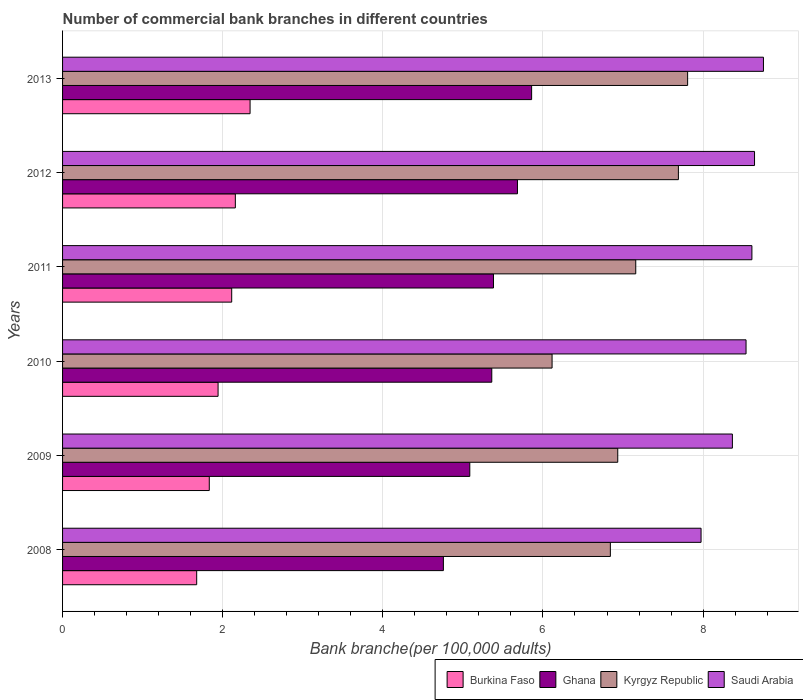How many different coloured bars are there?
Keep it short and to the point. 4. How many groups of bars are there?
Your response must be concise. 6. Are the number of bars per tick equal to the number of legend labels?
Keep it short and to the point. Yes. Are the number of bars on each tick of the Y-axis equal?
Keep it short and to the point. Yes. How many bars are there on the 1st tick from the top?
Keep it short and to the point. 4. What is the label of the 5th group of bars from the top?
Your response must be concise. 2009. In how many cases, is the number of bars for a given year not equal to the number of legend labels?
Ensure brevity in your answer.  0. What is the number of commercial bank branches in Saudi Arabia in 2013?
Give a very brief answer. 8.75. Across all years, what is the maximum number of commercial bank branches in Saudi Arabia?
Ensure brevity in your answer.  8.75. Across all years, what is the minimum number of commercial bank branches in Kyrgyz Republic?
Your response must be concise. 6.11. What is the total number of commercial bank branches in Ghana in the graph?
Make the answer very short. 32.13. What is the difference between the number of commercial bank branches in Kyrgyz Republic in 2010 and that in 2012?
Give a very brief answer. -1.58. What is the difference between the number of commercial bank branches in Saudi Arabia in 2010 and the number of commercial bank branches in Kyrgyz Republic in 2011?
Provide a short and direct response. 1.38. What is the average number of commercial bank branches in Ghana per year?
Your answer should be very brief. 5.35. In the year 2012, what is the difference between the number of commercial bank branches in Ghana and number of commercial bank branches in Kyrgyz Republic?
Offer a very short reply. -2.01. What is the ratio of the number of commercial bank branches in Ghana in 2012 to that in 2013?
Your answer should be very brief. 0.97. Is the number of commercial bank branches in Ghana in 2008 less than that in 2012?
Keep it short and to the point. Yes. What is the difference between the highest and the second highest number of commercial bank branches in Kyrgyz Republic?
Your answer should be compact. 0.12. What is the difference between the highest and the lowest number of commercial bank branches in Burkina Faso?
Provide a succinct answer. 0.67. Is the sum of the number of commercial bank branches in Ghana in 2008 and 2009 greater than the maximum number of commercial bank branches in Burkina Faso across all years?
Give a very brief answer. Yes. Is it the case that in every year, the sum of the number of commercial bank branches in Ghana and number of commercial bank branches in Burkina Faso is greater than the sum of number of commercial bank branches in Kyrgyz Republic and number of commercial bank branches in Saudi Arabia?
Your response must be concise. No. What does the 1st bar from the top in 2013 represents?
Offer a very short reply. Saudi Arabia. What does the 4th bar from the bottom in 2013 represents?
Provide a short and direct response. Saudi Arabia. Is it the case that in every year, the sum of the number of commercial bank branches in Burkina Faso and number of commercial bank branches in Kyrgyz Republic is greater than the number of commercial bank branches in Saudi Arabia?
Offer a very short reply. No. What is the difference between two consecutive major ticks on the X-axis?
Give a very brief answer. 2. Does the graph contain any zero values?
Make the answer very short. No. Does the graph contain grids?
Your response must be concise. Yes. Where does the legend appear in the graph?
Your answer should be very brief. Bottom right. What is the title of the graph?
Provide a short and direct response. Number of commercial bank branches in different countries. What is the label or title of the X-axis?
Provide a succinct answer. Bank branche(per 100,0 adults). What is the label or title of the Y-axis?
Offer a terse response. Years. What is the Bank branche(per 100,000 adults) of Burkina Faso in 2008?
Make the answer very short. 1.68. What is the Bank branche(per 100,000 adults) of Ghana in 2008?
Offer a very short reply. 4.76. What is the Bank branche(per 100,000 adults) of Kyrgyz Republic in 2008?
Ensure brevity in your answer.  6.84. What is the Bank branche(per 100,000 adults) of Saudi Arabia in 2008?
Your answer should be very brief. 7.97. What is the Bank branche(per 100,000 adults) of Burkina Faso in 2009?
Your answer should be very brief. 1.83. What is the Bank branche(per 100,000 adults) of Ghana in 2009?
Your answer should be very brief. 5.09. What is the Bank branche(per 100,000 adults) of Kyrgyz Republic in 2009?
Ensure brevity in your answer.  6.93. What is the Bank branche(per 100,000 adults) of Saudi Arabia in 2009?
Keep it short and to the point. 8.37. What is the Bank branche(per 100,000 adults) of Burkina Faso in 2010?
Your answer should be very brief. 1.94. What is the Bank branche(per 100,000 adults) in Ghana in 2010?
Keep it short and to the point. 5.36. What is the Bank branche(per 100,000 adults) in Kyrgyz Republic in 2010?
Provide a short and direct response. 6.11. What is the Bank branche(per 100,000 adults) in Saudi Arabia in 2010?
Your answer should be very brief. 8.54. What is the Bank branche(per 100,000 adults) of Burkina Faso in 2011?
Give a very brief answer. 2.11. What is the Bank branche(per 100,000 adults) of Ghana in 2011?
Your answer should be very brief. 5.38. What is the Bank branche(per 100,000 adults) in Kyrgyz Republic in 2011?
Provide a short and direct response. 7.16. What is the Bank branche(per 100,000 adults) of Saudi Arabia in 2011?
Ensure brevity in your answer.  8.61. What is the Bank branche(per 100,000 adults) of Burkina Faso in 2012?
Offer a terse response. 2.16. What is the Bank branche(per 100,000 adults) of Ghana in 2012?
Offer a very short reply. 5.68. What is the Bank branche(per 100,000 adults) in Kyrgyz Republic in 2012?
Ensure brevity in your answer.  7.69. What is the Bank branche(per 100,000 adults) of Saudi Arabia in 2012?
Ensure brevity in your answer.  8.64. What is the Bank branche(per 100,000 adults) in Burkina Faso in 2013?
Provide a short and direct response. 2.34. What is the Bank branche(per 100,000 adults) in Ghana in 2013?
Offer a terse response. 5.86. What is the Bank branche(per 100,000 adults) of Kyrgyz Republic in 2013?
Your response must be concise. 7.81. What is the Bank branche(per 100,000 adults) in Saudi Arabia in 2013?
Your answer should be very brief. 8.75. Across all years, what is the maximum Bank branche(per 100,000 adults) of Burkina Faso?
Offer a terse response. 2.34. Across all years, what is the maximum Bank branche(per 100,000 adults) of Ghana?
Offer a terse response. 5.86. Across all years, what is the maximum Bank branche(per 100,000 adults) of Kyrgyz Republic?
Your response must be concise. 7.81. Across all years, what is the maximum Bank branche(per 100,000 adults) of Saudi Arabia?
Your response must be concise. 8.75. Across all years, what is the minimum Bank branche(per 100,000 adults) in Burkina Faso?
Provide a succinct answer. 1.68. Across all years, what is the minimum Bank branche(per 100,000 adults) in Ghana?
Give a very brief answer. 4.76. Across all years, what is the minimum Bank branche(per 100,000 adults) in Kyrgyz Republic?
Offer a very short reply. 6.11. Across all years, what is the minimum Bank branche(per 100,000 adults) of Saudi Arabia?
Your response must be concise. 7.97. What is the total Bank branche(per 100,000 adults) in Burkina Faso in the graph?
Your answer should be very brief. 12.06. What is the total Bank branche(per 100,000 adults) in Ghana in the graph?
Provide a short and direct response. 32.13. What is the total Bank branche(per 100,000 adults) in Kyrgyz Republic in the graph?
Keep it short and to the point. 42.55. What is the total Bank branche(per 100,000 adults) of Saudi Arabia in the graph?
Your response must be concise. 50.88. What is the difference between the Bank branche(per 100,000 adults) of Burkina Faso in 2008 and that in 2009?
Provide a succinct answer. -0.16. What is the difference between the Bank branche(per 100,000 adults) in Ghana in 2008 and that in 2009?
Provide a short and direct response. -0.33. What is the difference between the Bank branche(per 100,000 adults) in Kyrgyz Republic in 2008 and that in 2009?
Your response must be concise. -0.09. What is the difference between the Bank branche(per 100,000 adults) in Saudi Arabia in 2008 and that in 2009?
Provide a succinct answer. -0.39. What is the difference between the Bank branche(per 100,000 adults) of Burkina Faso in 2008 and that in 2010?
Offer a terse response. -0.27. What is the difference between the Bank branche(per 100,000 adults) of Ghana in 2008 and that in 2010?
Provide a succinct answer. -0.6. What is the difference between the Bank branche(per 100,000 adults) of Kyrgyz Republic in 2008 and that in 2010?
Your answer should be compact. 0.73. What is the difference between the Bank branche(per 100,000 adults) of Saudi Arabia in 2008 and that in 2010?
Give a very brief answer. -0.56. What is the difference between the Bank branche(per 100,000 adults) of Burkina Faso in 2008 and that in 2011?
Ensure brevity in your answer.  -0.44. What is the difference between the Bank branche(per 100,000 adults) in Ghana in 2008 and that in 2011?
Offer a very short reply. -0.63. What is the difference between the Bank branche(per 100,000 adults) of Kyrgyz Republic in 2008 and that in 2011?
Offer a terse response. -0.32. What is the difference between the Bank branche(per 100,000 adults) of Saudi Arabia in 2008 and that in 2011?
Offer a very short reply. -0.63. What is the difference between the Bank branche(per 100,000 adults) of Burkina Faso in 2008 and that in 2012?
Give a very brief answer. -0.48. What is the difference between the Bank branche(per 100,000 adults) of Ghana in 2008 and that in 2012?
Provide a short and direct response. -0.93. What is the difference between the Bank branche(per 100,000 adults) in Kyrgyz Republic in 2008 and that in 2012?
Offer a terse response. -0.85. What is the difference between the Bank branche(per 100,000 adults) in Saudi Arabia in 2008 and that in 2012?
Keep it short and to the point. -0.67. What is the difference between the Bank branche(per 100,000 adults) of Burkina Faso in 2008 and that in 2013?
Your answer should be very brief. -0.67. What is the difference between the Bank branche(per 100,000 adults) of Ghana in 2008 and that in 2013?
Your response must be concise. -1.1. What is the difference between the Bank branche(per 100,000 adults) of Kyrgyz Republic in 2008 and that in 2013?
Provide a succinct answer. -0.96. What is the difference between the Bank branche(per 100,000 adults) in Saudi Arabia in 2008 and that in 2013?
Ensure brevity in your answer.  -0.78. What is the difference between the Bank branche(per 100,000 adults) of Burkina Faso in 2009 and that in 2010?
Make the answer very short. -0.11. What is the difference between the Bank branche(per 100,000 adults) in Ghana in 2009 and that in 2010?
Offer a terse response. -0.27. What is the difference between the Bank branche(per 100,000 adults) of Kyrgyz Republic in 2009 and that in 2010?
Ensure brevity in your answer.  0.82. What is the difference between the Bank branche(per 100,000 adults) of Saudi Arabia in 2009 and that in 2010?
Provide a succinct answer. -0.17. What is the difference between the Bank branche(per 100,000 adults) of Burkina Faso in 2009 and that in 2011?
Your response must be concise. -0.28. What is the difference between the Bank branche(per 100,000 adults) of Ghana in 2009 and that in 2011?
Your answer should be compact. -0.3. What is the difference between the Bank branche(per 100,000 adults) in Kyrgyz Republic in 2009 and that in 2011?
Give a very brief answer. -0.22. What is the difference between the Bank branche(per 100,000 adults) of Saudi Arabia in 2009 and that in 2011?
Offer a terse response. -0.24. What is the difference between the Bank branche(per 100,000 adults) of Burkina Faso in 2009 and that in 2012?
Ensure brevity in your answer.  -0.33. What is the difference between the Bank branche(per 100,000 adults) of Ghana in 2009 and that in 2012?
Keep it short and to the point. -0.6. What is the difference between the Bank branche(per 100,000 adults) in Kyrgyz Republic in 2009 and that in 2012?
Offer a terse response. -0.76. What is the difference between the Bank branche(per 100,000 adults) of Saudi Arabia in 2009 and that in 2012?
Give a very brief answer. -0.28. What is the difference between the Bank branche(per 100,000 adults) of Burkina Faso in 2009 and that in 2013?
Make the answer very short. -0.51. What is the difference between the Bank branche(per 100,000 adults) of Ghana in 2009 and that in 2013?
Keep it short and to the point. -0.77. What is the difference between the Bank branche(per 100,000 adults) in Kyrgyz Republic in 2009 and that in 2013?
Your answer should be very brief. -0.87. What is the difference between the Bank branche(per 100,000 adults) in Saudi Arabia in 2009 and that in 2013?
Ensure brevity in your answer.  -0.39. What is the difference between the Bank branche(per 100,000 adults) of Burkina Faso in 2010 and that in 2011?
Your answer should be compact. -0.17. What is the difference between the Bank branche(per 100,000 adults) in Ghana in 2010 and that in 2011?
Your response must be concise. -0.02. What is the difference between the Bank branche(per 100,000 adults) of Kyrgyz Republic in 2010 and that in 2011?
Your answer should be very brief. -1.05. What is the difference between the Bank branche(per 100,000 adults) in Saudi Arabia in 2010 and that in 2011?
Provide a short and direct response. -0.07. What is the difference between the Bank branche(per 100,000 adults) of Burkina Faso in 2010 and that in 2012?
Provide a short and direct response. -0.22. What is the difference between the Bank branche(per 100,000 adults) of Ghana in 2010 and that in 2012?
Offer a terse response. -0.32. What is the difference between the Bank branche(per 100,000 adults) in Kyrgyz Republic in 2010 and that in 2012?
Offer a very short reply. -1.58. What is the difference between the Bank branche(per 100,000 adults) in Saudi Arabia in 2010 and that in 2012?
Provide a succinct answer. -0.11. What is the difference between the Bank branche(per 100,000 adults) in Burkina Faso in 2010 and that in 2013?
Offer a terse response. -0.4. What is the difference between the Bank branche(per 100,000 adults) of Ghana in 2010 and that in 2013?
Offer a very short reply. -0.5. What is the difference between the Bank branche(per 100,000 adults) of Kyrgyz Republic in 2010 and that in 2013?
Give a very brief answer. -1.69. What is the difference between the Bank branche(per 100,000 adults) in Saudi Arabia in 2010 and that in 2013?
Offer a very short reply. -0.22. What is the difference between the Bank branche(per 100,000 adults) of Burkina Faso in 2011 and that in 2012?
Ensure brevity in your answer.  -0.05. What is the difference between the Bank branche(per 100,000 adults) of Ghana in 2011 and that in 2012?
Your response must be concise. -0.3. What is the difference between the Bank branche(per 100,000 adults) in Kyrgyz Republic in 2011 and that in 2012?
Your answer should be compact. -0.53. What is the difference between the Bank branche(per 100,000 adults) in Saudi Arabia in 2011 and that in 2012?
Give a very brief answer. -0.03. What is the difference between the Bank branche(per 100,000 adults) of Burkina Faso in 2011 and that in 2013?
Give a very brief answer. -0.23. What is the difference between the Bank branche(per 100,000 adults) in Ghana in 2011 and that in 2013?
Ensure brevity in your answer.  -0.48. What is the difference between the Bank branche(per 100,000 adults) in Kyrgyz Republic in 2011 and that in 2013?
Offer a very short reply. -0.65. What is the difference between the Bank branche(per 100,000 adults) in Saudi Arabia in 2011 and that in 2013?
Give a very brief answer. -0.14. What is the difference between the Bank branche(per 100,000 adults) of Burkina Faso in 2012 and that in 2013?
Provide a short and direct response. -0.18. What is the difference between the Bank branche(per 100,000 adults) of Ghana in 2012 and that in 2013?
Your answer should be compact. -0.18. What is the difference between the Bank branche(per 100,000 adults) in Kyrgyz Republic in 2012 and that in 2013?
Provide a succinct answer. -0.12. What is the difference between the Bank branche(per 100,000 adults) of Saudi Arabia in 2012 and that in 2013?
Your answer should be compact. -0.11. What is the difference between the Bank branche(per 100,000 adults) in Burkina Faso in 2008 and the Bank branche(per 100,000 adults) in Ghana in 2009?
Give a very brief answer. -3.41. What is the difference between the Bank branche(per 100,000 adults) of Burkina Faso in 2008 and the Bank branche(per 100,000 adults) of Kyrgyz Republic in 2009?
Provide a succinct answer. -5.26. What is the difference between the Bank branche(per 100,000 adults) of Burkina Faso in 2008 and the Bank branche(per 100,000 adults) of Saudi Arabia in 2009?
Your answer should be very brief. -6.69. What is the difference between the Bank branche(per 100,000 adults) of Ghana in 2008 and the Bank branche(per 100,000 adults) of Kyrgyz Republic in 2009?
Give a very brief answer. -2.18. What is the difference between the Bank branche(per 100,000 adults) of Ghana in 2008 and the Bank branche(per 100,000 adults) of Saudi Arabia in 2009?
Give a very brief answer. -3.61. What is the difference between the Bank branche(per 100,000 adults) of Kyrgyz Republic in 2008 and the Bank branche(per 100,000 adults) of Saudi Arabia in 2009?
Your response must be concise. -1.52. What is the difference between the Bank branche(per 100,000 adults) in Burkina Faso in 2008 and the Bank branche(per 100,000 adults) in Ghana in 2010?
Give a very brief answer. -3.69. What is the difference between the Bank branche(per 100,000 adults) in Burkina Faso in 2008 and the Bank branche(per 100,000 adults) in Kyrgyz Republic in 2010?
Provide a succinct answer. -4.44. What is the difference between the Bank branche(per 100,000 adults) in Burkina Faso in 2008 and the Bank branche(per 100,000 adults) in Saudi Arabia in 2010?
Keep it short and to the point. -6.86. What is the difference between the Bank branche(per 100,000 adults) in Ghana in 2008 and the Bank branche(per 100,000 adults) in Kyrgyz Republic in 2010?
Ensure brevity in your answer.  -1.36. What is the difference between the Bank branche(per 100,000 adults) in Ghana in 2008 and the Bank branche(per 100,000 adults) in Saudi Arabia in 2010?
Offer a very short reply. -3.78. What is the difference between the Bank branche(per 100,000 adults) of Kyrgyz Republic in 2008 and the Bank branche(per 100,000 adults) of Saudi Arabia in 2010?
Make the answer very short. -1.69. What is the difference between the Bank branche(per 100,000 adults) of Burkina Faso in 2008 and the Bank branche(per 100,000 adults) of Ghana in 2011?
Your answer should be compact. -3.71. What is the difference between the Bank branche(per 100,000 adults) of Burkina Faso in 2008 and the Bank branche(per 100,000 adults) of Kyrgyz Republic in 2011?
Keep it short and to the point. -5.48. What is the difference between the Bank branche(per 100,000 adults) in Burkina Faso in 2008 and the Bank branche(per 100,000 adults) in Saudi Arabia in 2011?
Make the answer very short. -6.93. What is the difference between the Bank branche(per 100,000 adults) of Ghana in 2008 and the Bank branche(per 100,000 adults) of Kyrgyz Republic in 2011?
Your answer should be very brief. -2.4. What is the difference between the Bank branche(per 100,000 adults) of Ghana in 2008 and the Bank branche(per 100,000 adults) of Saudi Arabia in 2011?
Make the answer very short. -3.85. What is the difference between the Bank branche(per 100,000 adults) of Kyrgyz Republic in 2008 and the Bank branche(per 100,000 adults) of Saudi Arabia in 2011?
Provide a succinct answer. -1.77. What is the difference between the Bank branche(per 100,000 adults) in Burkina Faso in 2008 and the Bank branche(per 100,000 adults) in Ghana in 2012?
Give a very brief answer. -4.01. What is the difference between the Bank branche(per 100,000 adults) of Burkina Faso in 2008 and the Bank branche(per 100,000 adults) of Kyrgyz Republic in 2012?
Provide a short and direct response. -6.02. What is the difference between the Bank branche(per 100,000 adults) of Burkina Faso in 2008 and the Bank branche(per 100,000 adults) of Saudi Arabia in 2012?
Your response must be concise. -6.97. What is the difference between the Bank branche(per 100,000 adults) in Ghana in 2008 and the Bank branche(per 100,000 adults) in Kyrgyz Republic in 2012?
Keep it short and to the point. -2.94. What is the difference between the Bank branche(per 100,000 adults) in Ghana in 2008 and the Bank branche(per 100,000 adults) in Saudi Arabia in 2012?
Offer a terse response. -3.89. What is the difference between the Bank branche(per 100,000 adults) in Kyrgyz Republic in 2008 and the Bank branche(per 100,000 adults) in Saudi Arabia in 2012?
Ensure brevity in your answer.  -1.8. What is the difference between the Bank branche(per 100,000 adults) in Burkina Faso in 2008 and the Bank branche(per 100,000 adults) in Ghana in 2013?
Provide a short and direct response. -4.18. What is the difference between the Bank branche(per 100,000 adults) in Burkina Faso in 2008 and the Bank branche(per 100,000 adults) in Kyrgyz Republic in 2013?
Provide a short and direct response. -6.13. What is the difference between the Bank branche(per 100,000 adults) of Burkina Faso in 2008 and the Bank branche(per 100,000 adults) of Saudi Arabia in 2013?
Give a very brief answer. -7.08. What is the difference between the Bank branche(per 100,000 adults) in Ghana in 2008 and the Bank branche(per 100,000 adults) in Kyrgyz Republic in 2013?
Your response must be concise. -3.05. What is the difference between the Bank branche(per 100,000 adults) of Ghana in 2008 and the Bank branche(per 100,000 adults) of Saudi Arabia in 2013?
Keep it short and to the point. -4. What is the difference between the Bank branche(per 100,000 adults) of Kyrgyz Republic in 2008 and the Bank branche(per 100,000 adults) of Saudi Arabia in 2013?
Give a very brief answer. -1.91. What is the difference between the Bank branche(per 100,000 adults) of Burkina Faso in 2009 and the Bank branche(per 100,000 adults) of Ghana in 2010?
Make the answer very short. -3.53. What is the difference between the Bank branche(per 100,000 adults) of Burkina Faso in 2009 and the Bank branche(per 100,000 adults) of Kyrgyz Republic in 2010?
Offer a very short reply. -4.28. What is the difference between the Bank branche(per 100,000 adults) in Burkina Faso in 2009 and the Bank branche(per 100,000 adults) in Saudi Arabia in 2010?
Give a very brief answer. -6.7. What is the difference between the Bank branche(per 100,000 adults) in Ghana in 2009 and the Bank branche(per 100,000 adults) in Kyrgyz Republic in 2010?
Give a very brief answer. -1.03. What is the difference between the Bank branche(per 100,000 adults) of Ghana in 2009 and the Bank branche(per 100,000 adults) of Saudi Arabia in 2010?
Give a very brief answer. -3.45. What is the difference between the Bank branche(per 100,000 adults) of Kyrgyz Republic in 2009 and the Bank branche(per 100,000 adults) of Saudi Arabia in 2010?
Ensure brevity in your answer.  -1.6. What is the difference between the Bank branche(per 100,000 adults) of Burkina Faso in 2009 and the Bank branche(per 100,000 adults) of Ghana in 2011?
Provide a succinct answer. -3.55. What is the difference between the Bank branche(per 100,000 adults) in Burkina Faso in 2009 and the Bank branche(per 100,000 adults) in Kyrgyz Republic in 2011?
Offer a very short reply. -5.33. What is the difference between the Bank branche(per 100,000 adults) of Burkina Faso in 2009 and the Bank branche(per 100,000 adults) of Saudi Arabia in 2011?
Keep it short and to the point. -6.78. What is the difference between the Bank branche(per 100,000 adults) in Ghana in 2009 and the Bank branche(per 100,000 adults) in Kyrgyz Republic in 2011?
Make the answer very short. -2.07. What is the difference between the Bank branche(per 100,000 adults) in Ghana in 2009 and the Bank branche(per 100,000 adults) in Saudi Arabia in 2011?
Your answer should be compact. -3.52. What is the difference between the Bank branche(per 100,000 adults) of Kyrgyz Republic in 2009 and the Bank branche(per 100,000 adults) of Saudi Arabia in 2011?
Your answer should be very brief. -1.68. What is the difference between the Bank branche(per 100,000 adults) of Burkina Faso in 2009 and the Bank branche(per 100,000 adults) of Ghana in 2012?
Provide a succinct answer. -3.85. What is the difference between the Bank branche(per 100,000 adults) in Burkina Faso in 2009 and the Bank branche(per 100,000 adults) in Kyrgyz Republic in 2012?
Provide a short and direct response. -5.86. What is the difference between the Bank branche(per 100,000 adults) in Burkina Faso in 2009 and the Bank branche(per 100,000 adults) in Saudi Arabia in 2012?
Ensure brevity in your answer.  -6.81. What is the difference between the Bank branche(per 100,000 adults) in Ghana in 2009 and the Bank branche(per 100,000 adults) in Kyrgyz Republic in 2012?
Offer a very short reply. -2.61. What is the difference between the Bank branche(per 100,000 adults) of Ghana in 2009 and the Bank branche(per 100,000 adults) of Saudi Arabia in 2012?
Make the answer very short. -3.56. What is the difference between the Bank branche(per 100,000 adults) of Kyrgyz Republic in 2009 and the Bank branche(per 100,000 adults) of Saudi Arabia in 2012?
Provide a succinct answer. -1.71. What is the difference between the Bank branche(per 100,000 adults) in Burkina Faso in 2009 and the Bank branche(per 100,000 adults) in Ghana in 2013?
Offer a very short reply. -4.03. What is the difference between the Bank branche(per 100,000 adults) in Burkina Faso in 2009 and the Bank branche(per 100,000 adults) in Kyrgyz Republic in 2013?
Give a very brief answer. -5.97. What is the difference between the Bank branche(per 100,000 adults) in Burkina Faso in 2009 and the Bank branche(per 100,000 adults) in Saudi Arabia in 2013?
Make the answer very short. -6.92. What is the difference between the Bank branche(per 100,000 adults) in Ghana in 2009 and the Bank branche(per 100,000 adults) in Kyrgyz Republic in 2013?
Provide a succinct answer. -2.72. What is the difference between the Bank branche(per 100,000 adults) in Ghana in 2009 and the Bank branche(per 100,000 adults) in Saudi Arabia in 2013?
Your response must be concise. -3.67. What is the difference between the Bank branche(per 100,000 adults) in Kyrgyz Republic in 2009 and the Bank branche(per 100,000 adults) in Saudi Arabia in 2013?
Make the answer very short. -1.82. What is the difference between the Bank branche(per 100,000 adults) of Burkina Faso in 2010 and the Bank branche(per 100,000 adults) of Ghana in 2011?
Keep it short and to the point. -3.44. What is the difference between the Bank branche(per 100,000 adults) of Burkina Faso in 2010 and the Bank branche(per 100,000 adults) of Kyrgyz Republic in 2011?
Your answer should be compact. -5.22. What is the difference between the Bank branche(per 100,000 adults) in Burkina Faso in 2010 and the Bank branche(per 100,000 adults) in Saudi Arabia in 2011?
Your answer should be compact. -6.67. What is the difference between the Bank branche(per 100,000 adults) in Ghana in 2010 and the Bank branche(per 100,000 adults) in Kyrgyz Republic in 2011?
Offer a terse response. -1.8. What is the difference between the Bank branche(per 100,000 adults) in Ghana in 2010 and the Bank branche(per 100,000 adults) in Saudi Arabia in 2011?
Your response must be concise. -3.25. What is the difference between the Bank branche(per 100,000 adults) of Kyrgyz Republic in 2010 and the Bank branche(per 100,000 adults) of Saudi Arabia in 2011?
Provide a short and direct response. -2.5. What is the difference between the Bank branche(per 100,000 adults) in Burkina Faso in 2010 and the Bank branche(per 100,000 adults) in Ghana in 2012?
Keep it short and to the point. -3.74. What is the difference between the Bank branche(per 100,000 adults) in Burkina Faso in 2010 and the Bank branche(per 100,000 adults) in Kyrgyz Republic in 2012?
Offer a terse response. -5.75. What is the difference between the Bank branche(per 100,000 adults) in Burkina Faso in 2010 and the Bank branche(per 100,000 adults) in Saudi Arabia in 2012?
Offer a terse response. -6.7. What is the difference between the Bank branche(per 100,000 adults) of Ghana in 2010 and the Bank branche(per 100,000 adults) of Kyrgyz Republic in 2012?
Provide a succinct answer. -2.33. What is the difference between the Bank branche(per 100,000 adults) in Ghana in 2010 and the Bank branche(per 100,000 adults) in Saudi Arabia in 2012?
Your answer should be very brief. -3.28. What is the difference between the Bank branche(per 100,000 adults) of Kyrgyz Republic in 2010 and the Bank branche(per 100,000 adults) of Saudi Arabia in 2012?
Offer a terse response. -2.53. What is the difference between the Bank branche(per 100,000 adults) of Burkina Faso in 2010 and the Bank branche(per 100,000 adults) of Ghana in 2013?
Give a very brief answer. -3.92. What is the difference between the Bank branche(per 100,000 adults) in Burkina Faso in 2010 and the Bank branche(per 100,000 adults) in Kyrgyz Republic in 2013?
Your response must be concise. -5.86. What is the difference between the Bank branche(per 100,000 adults) in Burkina Faso in 2010 and the Bank branche(per 100,000 adults) in Saudi Arabia in 2013?
Offer a terse response. -6.81. What is the difference between the Bank branche(per 100,000 adults) of Ghana in 2010 and the Bank branche(per 100,000 adults) of Kyrgyz Republic in 2013?
Provide a short and direct response. -2.45. What is the difference between the Bank branche(per 100,000 adults) in Ghana in 2010 and the Bank branche(per 100,000 adults) in Saudi Arabia in 2013?
Your response must be concise. -3.39. What is the difference between the Bank branche(per 100,000 adults) of Kyrgyz Republic in 2010 and the Bank branche(per 100,000 adults) of Saudi Arabia in 2013?
Provide a short and direct response. -2.64. What is the difference between the Bank branche(per 100,000 adults) of Burkina Faso in 2011 and the Bank branche(per 100,000 adults) of Ghana in 2012?
Offer a very short reply. -3.57. What is the difference between the Bank branche(per 100,000 adults) in Burkina Faso in 2011 and the Bank branche(per 100,000 adults) in Kyrgyz Republic in 2012?
Give a very brief answer. -5.58. What is the difference between the Bank branche(per 100,000 adults) of Burkina Faso in 2011 and the Bank branche(per 100,000 adults) of Saudi Arabia in 2012?
Ensure brevity in your answer.  -6.53. What is the difference between the Bank branche(per 100,000 adults) in Ghana in 2011 and the Bank branche(per 100,000 adults) in Kyrgyz Republic in 2012?
Your answer should be compact. -2.31. What is the difference between the Bank branche(per 100,000 adults) in Ghana in 2011 and the Bank branche(per 100,000 adults) in Saudi Arabia in 2012?
Offer a terse response. -3.26. What is the difference between the Bank branche(per 100,000 adults) of Kyrgyz Republic in 2011 and the Bank branche(per 100,000 adults) of Saudi Arabia in 2012?
Make the answer very short. -1.48. What is the difference between the Bank branche(per 100,000 adults) of Burkina Faso in 2011 and the Bank branche(per 100,000 adults) of Ghana in 2013?
Your response must be concise. -3.75. What is the difference between the Bank branche(per 100,000 adults) in Burkina Faso in 2011 and the Bank branche(per 100,000 adults) in Kyrgyz Republic in 2013?
Give a very brief answer. -5.69. What is the difference between the Bank branche(per 100,000 adults) of Burkina Faso in 2011 and the Bank branche(per 100,000 adults) of Saudi Arabia in 2013?
Your response must be concise. -6.64. What is the difference between the Bank branche(per 100,000 adults) in Ghana in 2011 and the Bank branche(per 100,000 adults) in Kyrgyz Republic in 2013?
Keep it short and to the point. -2.42. What is the difference between the Bank branche(per 100,000 adults) in Ghana in 2011 and the Bank branche(per 100,000 adults) in Saudi Arabia in 2013?
Make the answer very short. -3.37. What is the difference between the Bank branche(per 100,000 adults) of Kyrgyz Republic in 2011 and the Bank branche(per 100,000 adults) of Saudi Arabia in 2013?
Your answer should be very brief. -1.59. What is the difference between the Bank branche(per 100,000 adults) in Burkina Faso in 2012 and the Bank branche(per 100,000 adults) in Ghana in 2013?
Your answer should be very brief. -3.7. What is the difference between the Bank branche(per 100,000 adults) of Burkina Faso in 2012 and the Bank branche(per 100,000 adults) of Kyrgyz Republic in 2013?
Provide a short and direct response. -5.65. What is the difference between the Bank branche(per 100,000 adults) of Burkina Faso in 2012 and the Bank branche(per 100,000 adults) of Saudi Arabia in 2013?
Make the answer very short. -6.6. What is the difference between the Bank branche(per 100,000 adults) of Ghana in 2012 and the Bank branche(per 100,000 adults) of Kyrgyz Republic in 2013?
Your response must be concise. -2.13. What is the difference between the Bank branche(per 100,000 adults) of Ghana in 2012 and the Bank branche(per 100,000 adults) of Saudi Arabia in 2013?
Offer a terse response. -3.07. What is the difference between the Bank branche(per 100,000 adults) in Kyrgyz Republic in 2012 and the Bank branche(per 100,000 adults) in Saudi Arabia in 2013?
Ensure brevity in your answer.  -1.06. What is the average Bank branche(per 100,000 adults) of Burkina Faso per year?
Ensure brevity in your answer.  2.01. What is the average Bank branche(per 100,000 adults) in Ghana per year?
Provide a short and direct response. 5.35. What is the average Bank branche(per 100,000 adults) of Kyrgyz Republic per year?
Your response must be concise. 7.09. What is the average Bank branche(per 100,000 adults) of Saudi Arabia per year?
Offer a very short reply. 8.48. In the year 2008, what is the difference between the Bank branche(per 100,000 adults) in Burkina Faso and Bank branche(per 100,000 adults) in Ghana?
Offer a very short reply. -3.08. In the year 2008, what is the difference between the Bank branche(per 100,000 adults) in Burkina Faso and Bank branche(per 100,000 adults) in Kyrgyz Republic?
Provide a short and direct response. -5.17. In the year 2008, what is the difference between the Bank branche(per 100,000 adults) in Burkina Faso and Bank branche(per 100,000 adults) in Saudi Arabia?
Keep it short and to the point. -6.3. In the year 2008, what is the difference between the Bank branche(per 100,000 adults) in Ghana and Bank branche(per 100,000 adults) in Kyrgyz Republic?
Make the answer very short. -2.09. In the year 2008, what is the difference between the Bank branche(per 100,000 adults) in Ghana and Bank branche(per 100,000 adults) in Saudi Arabia?
Offer a very short reply. -3.22. In the year 2008, what is the difference between the Bank branche(per 100,000 adults) in Kyrgyz Republic and Bank branche(per 100,000 adults) in Saudi Arabia?
Your answer should be very brief. -1.13. In the year 2009, what is the difference between the Bank branche(per 100,000 adults) in Burkina Faso and Bank branche(per 100,000 adults) in Ghana?
Provide a succinct answer. -3.25. In the year 2009, what is the difference between the Bank branche(per 100,000 adults) in Burkina Faso and Bank branche(per 100,000 adults) in Kyrgyz Republic?
Provide a short and direct response. -5.1. In the year 2009, what is the difference between the Bank branche(per 100,000 adults) of Burkina Faso and Bank branche(per 100,000 adults) of Saudi Arabia?
Offer a terse response. -6.53. In the year 2009, what is the difference between the Bank branche(per 100,000 adults) in Ghana and Bank branche(per 100,000 adults) in Kyrgyz Republic?
Ensure brevity in your answer.  -1.85. In the year 2009, what is the difference between the Bank branche(per 100,000 adults) in Ghana and Bank branche(per 100,000 adults) in Saudi Arabia?
Ensure brevity in your answer.  -3.28. In the year 2009, what is the difference between the Bank branche(per 100,000 adults) in Kyrgyz Republic and Bank branche(per 100,000 adults) in Saudi Arabia?
Your response must be concise. -1.43. In the year 2010, what is the difference between the Bank branche(per 100,000 adults) of Burkina Faso and Bank branche(per 100,000 adults) of Ghana?
Keep it short and to the point. -3.42. In the year 2010, what is the difference between the Bank branche(per 100,000 adults) in Burkina Faso and Bank branche(per 100,000 adults) in Kyrgyz Republic?
Ensure brevity in your answer.  -4.17. In the year 2010, what is the difference between the Bank branche(per 100,000 adults) in Burkina Faso and Bank branche(per 100,000 adults) in Saudi Arabia?
Offer a terse response. -6.59. In the year 2010, what is the difference between the Bank branche(per 100,000 adults) of Ghana and Bank branche(per 100,000 adults) of Kyrgyz Republic?
Offer a terse response. -0.75. In the year 2010, what is the difference between the Bank branche(per 100,000 adults) of Ghana and Bank branche(per 100,000 adults) of Saudi Arabia?
Your response must be concise. -3.18. In the year 2010, what is the difference between the Bank branche(per 100,000 adults) of Kyrgyz Republic and Bank branche(per 100,000 adults) of Saudi Arabia?
Ensure brevity in your answer.  -2.42. In the year 2011, what is the difference between the Bank branche(per 100,000 adults) of Burkina Faso and Bank branche(per 100,000 adults) of Ghana?
Provide a short and direct response. -3.27. In the year 2011, what is the difference between the Bank branche(per 100,000 adults) of Burkina Faso and Bank branche(per 100,000 adults) of Kyrgyz Republic?
Keep it short and to the point. -5.05. In the year 2011, what is the difference between the Bank branche(per 100,000 adults) of Burkina Faso and Bank branche(per 100,000 adults) of Saudi Arabia?
Keep it short and to the point. -6.5. In the year 2011, what is the difference between the Bank branche(per 100,000 adults) of Ghana and Bank branche(per 100,000 adults) of Kyrgyz Republic?
Provide a short and direct response. -1.78. In the year 2011, what is the difference between the Bank branche(per 100,000 adults) of Ghana and Bank branche(per 100,000 adults) of Saudi Arabia?
Ensure brevity in your answer.  -3.23. In the year 2011, what is the difference between the Bank branche(per 100,000 adults) of Kyrgyz Republic and Bank branche(per 100,000 adults) of Saudi Arabia?
Your response must be concise. -1.45. In the year 2012, what is the difference between the Bank branche(per 100,000 adults) of Burkina Faso and Bank branche(per 100,000 adults) of Ghana?
Offer a very short reply. -3.52. In the year 2012, what is the difference between the Bank branche(per 100,000 adults) of Burkina Faso and Bank branche(per 100,000 adults) of Kyrgyz Republic?
Provide a short and direct response. -5.53. In the year 2012, what is the difference between the Bank branche(per 100,000 adults) in Burkina Faso and Bank branche(per 100,000 adults) in Saudi Arabia?
Your answer should be compact. -6.48. In the year 2012, what is the difference between the Bank branche(per 100,000 adults) in Ghana and Bank branche(per 100,000 adults) in Kyrgyz Republic?
Provide a short and direct response. -2.01. In the year 2012, what is the difference between the Bank branche(per 100,000 adults) in Ghana and Bank branche(per 100,000 adults) in Saudi Arabia?
Provide a succinct answer. -2.96. In the year 2012, what is the difference between the Bank branche(per 100,000 adults) of Kyrgyz Republic and Bank branche(per 100,000 adults) of Saudi Arabia?
Ensure brevity in your answer.  -0.95. In the year 2013, what is the difference between the Bank branche(per 100,000 adults) of Burkina Faso and Bank branche(per 100,000 adults) of Ghana?
Offer a terse response. -3.52. In the year 2013, what is the difference between the Bank branche(per 100,000 adults) of Burkina Faso and Bank branche(per 100,000 adults) of Kyrgyz Republic?
Keep it short and to the point. -5.46. In the year 2013, what is the difference between the Bank branche(per 100,000 adults) of Burkina Faso and Bank branche(per 100,000 adults) of Saudi Arabia?
Offer a terse response. -6.41. In the year 2013, what is the difference between the Bank branche(per 100,000 adults) in Ghana and Bank branche(per 100,000 adults) in Kyrgyz Republic?
Your answer should be very brief. -1.95. In the year 2013, what is the difference between the Bank branche(per 100,000 adults) in Ghana and Bank branche(per 100,000 adults) in Saudi Arabia?
Provide a succinct answer. -2.9. In the year 2013, what is the difference between the Bank branche(per 100,000 adults) in Kyrgyz Republic and Bank branche(per 100,000 adults) in Saudi Arabia?
Your answer should be very brief. -0.95. What is the ratio of the Bank branche(per 100,000 adults) of Burkina Faso in 2008 to that in 2009?
Provide a short and direct response. 0.91. What is the ratio of the Bank branche(per 100,000 adults) of Ghana in 2008 to that in 2009?
Keep it short and to the point. 0.94. What is the ratio of the Bank branche(per 100,000 adults) of Kyrgyz Republic in 2008 to that in 2009?
Provide a short and direct response. 0.99. What is the ratio of the Bank branche(per 100,000 adults) of Saudi Arabia in 2008 to that in 2009?
Your answer should be compact. 0.95. What is the ratio of the Bank branche(per 100,000 adults) of Burkina Faso in 2008 to that in 2010?
Give a very brief answer. 0.86. What is the ratio of the Bank branche(per 100,000 adults) of Ghana in 2008 to that in 2010?
Give a very brief answer. 0.89. What is the ratio of the Bank branche(per 100,000 adults) of Kyrgyz Republic in 2008 to that in 2010?
Your answer should be very brief. 1.12. What is the ratio of the Bank branche(per 100,000 adults) in Saudi Arabia in 2008 to that in 2010?
Give a very brief answer. 0.93. What is the ratio of the Bank branche(per 100,000 adults) of Burkina Faso in 2008 to that in 2011?
Keep it short and to the point. 0.79. What is the ratio of the Bank branche(per 100,000 adults) of Ghana in 2008 to that in 2011?
Your answer should be compact. 0.88. What is the ratio of the Bank branche(per 100,000 adults) of Kyrgyz Republic in 2008 to that in 2011?
Give a very brief answer. 0.96. What is the ratio of the Bank branche(per 100,000 adults) in Saudi Arabia in 2008 to that in 2011?
Make the answer very short. 0.93. What is the ratio of the Bank branche(per 100,000 adults) of Burkina Faso in 2008 to that in 2012?
Your answer should be very brief. 0.78. What is the ratio of the Bank branche(per 100,000 adults) in Ghana in 2008 to that in 2012?
Your response must be concise. 0.84. What is the ratio of the Bank branche(per 100,000 adults) of Kyrgyz Republic in 2008 to that in 2012?
Provide a succinct answer. 0.89. What is the ratio of the Bank branche(per 100,000 adults) in Saudi Arabia in 2008 to that in 2012?
Offer a terse response. 0.92. What is the ratio of the Bank branche(per 100,000 adults) in Burkina Faso in 2008 to that in 2013?
Give a very brief answer. 0.72. What is the ratio of the Bank branche(per 100,000 adults) in Ghana in 2008 to that in 2013?
Your answer should be compact. 0.81. What is the ratio of the Bank branche(per 100,000 adults) in Kyrgyz Republic in 2008 to that in 2013?
Your answer should be very brief. 0.88. What is the ratio of the Bank branche(per 100,000 adults) of Saudi Arabia in 2008 to that in 2013?
Keep it short and to the point. 0.91. What is the ratio of the Bank branche(per 100,000 adults) of Burkina Faso in 2009 to that in 2010?
Give a very brief answer. 0.94. What is the ratio of the Bank branche(per 100,000 adults) of Ghana in 2009 to that in 2010?
Keep it short and to the point. 0.95. What is the ratio of the Bank branche(per 100,000 adults) in Kyrgyz Republic in 2009 to that in 2010?
Offer a terse response. 1.13. What is the ratio of the Bank branche(per 100,000 adults) of Burkina Faso in 2009 to that in 2011?
Ensure brevity in your answer.  0.87. What is the ratio of the Bank branche(per 100,000 adults) of Ghana in 2009 to that in 2011?
Make the answer very short. 0.94. What is the ratio of the Bank branche(per 100,000 adults) of Kyrgyz Republic in 2009 to that in 2011?
Offer a very short reply. 0.97. What is the ratio of the Bank branche(per 100,000 adults) of Saudi Arabia in 2009 to that in 2011?
Your answer should be compact. 0.97. What is the ratio of the Bank branche(per 100,000 adults) in Burkina Faso in 2009 to that in 2012?
Provide a short and direct response. 0.85. What is the ratio of the Bank branche(per 100,000 adults) in Ghana in 2009 to that in 2012?
Offer a very short reply. 0.9. What is the ratio of the Bank branche(per 100,000 adults) of Kyrgyz Republic in 2009 to that in 2012?
Offer a terse response. 0.9. What is the ratio of the Bank branche(per 100,000 adults) in Burkina Faso in 2009 to that in 2013?
Offer a very short reply. 0.78. What is the ratio of the Bank branche(per 100,000 adults) in Ghana in 2009 to that in 2013?
Give a very brief answer. 0.87. What is the ratio of the Bank branche(per 100,000 adults) in Kyrgyz Republic in 2009 to that in 2013?
Your response must be concise. 0.89. What is the ratio of the Bank branche(per 100,000 adults) of Saudi Arabia in 2009 to that in 2013?
Offer a terse response. 0.96. What is the ratio of the Bank branche(per 100,000 adults) in Burkina Faso in 2010 to that in 2011?
Provide a succinct answer. 0.92. What is the ratio of the Bank branche(per 100,000 adults) of Kyrgyz Republic in 2010 to that in 2011?
Your answer should be very brief. 0.85. What is the ratio of the Bank branche(per 100,000 adults) of Saudi Arabia in 2010 to that in 2011?
Keep it short and to the point. 0.99. What is the ratio of the Bank branche(per 100,000 adults) in Burkina Faso in 2010 to that in 2012?
Your response must be concise. 0.9. What is the ratio of the Bank branche(per 100,000 adults) in Ghana in 2010 to that in 2012?
Provide a short and direct response. 0.94. What is the ratio of the Bank branche(per 100,000 adults) of Kyrgyz Republic in 2010 to that in 2012?
Provide a short and direct response. 0.79. What is the ratio of the Bank branche(per 100,000 adults) of Burkina Faso in 2010 to that in 2013?
Your answer should be very brief. 0.83. What is the ratio of the Bank branche(per 100,000 adults) in Ghana in 2010 to that in 2013?
Provide a succinct answer. 0.92. What is the ratio of the Bank branche(per 100,000 adults) of Kyrgyz Republic in 2010 to that in 2013?
Offer a terse response. 0.78. What is the ratio of the Bank branche(per 100,000 adults) of Saudi Arabia in 2010 to that in 2013?
Make the answer very short. 0.98. What is the ratio of the Bank branche(per 100,000 adults) of Burkina Faso in 2011 to that in 2012?
Make the answer very short. 0.98. What is the ratio of the Bank branche(per 100,000 adults) of Ghana in 2011 to that in 2012?
Your answer should be compact. 0.95. What is the ratio of the Bank branche(per 100,000 adults) of Kyrgyz Republic in 2011 to that in 2012?
Give a very brief answer. 0.93. What is the ratio of the Bank branche(per 100,000 adults) in Burkina Faso in 2011 to that in 2013?
Provide a short and direct response. 0.9. What is the ratio of the Bank branche(per 100,000 adults) in Ghana in 2011 to that in 2013?
Make the answer very short. 0.92. What is the ratio of the Bank branche(per 100,000 adults) of Kyrgyz Republic in 2011 to that in 2013?
Provide a short and direct response. 0.92. What is the ratio of the Bank branche(per 100,000 adults) of Saudi Arabia in 2011 to that in 2013?
Your answer should be very brief. 0.98. What is the ratio of the Bank branche(per 100,000 adults) of Burkina Faso in 2012 to that in 2013?
Your response must be concise. 0.92. What is the ratio of the Bank branche(per 100,000 adults) in Ghana in 2012 to that in 2013?
Your response must be concise. 0.97. What is the ratio of the Bank branche(per 100,000 adults) of Kyrgyz Republic in 2012 to that in 2013?
Ensure brevity in your answer.  0.99. What is the ratio of the Bank branche(per 100,000 adults) in Saudi Arabia in 2012 to that in 2013?
Make the answer very short. 0.99. What is the difference between the highest and the second highest Bank branche(per 100,000 adults) of Burkina Faso?
Offer a terse response. 0.18. What is the difference between the highest and the second highest Bank branche(per 100,000 adults) in Ghana?
Your response must be concise. 0.18. What is the difference between the highest and the second highest Bank branche(per 100,000 adults) in Kyrgyz Republic?
Give a very brief answer. 0.12. What is the difference between the highest and the second highest Bank branche(per 100,000 adults) in Saudi Arabia?
Your response must be concise. 0.11. What is the difference between the highest and the lowest Bank branche(per 100,000 adults) of Burkina Faso?
Keep it short and to the point. 0.67. What is the difference between the highest and the lowest Bank branche(per 100,000 adults) in Ghana?
Give a very brief answer. 1.1. What is the difference between the highest and the lowest Bank branche(per 100,000 adults) in Kyrgyz Republic?
Provide a succinct answer. 1.69. What is the difference between the highest and the lowest Bank branche(per 100,000 adults) in Saudi Arabia?
Give a very brief answer. 0.78. 